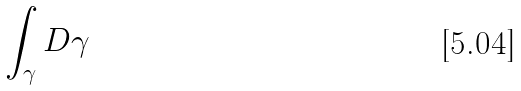Convert formula to latex. <formula><loc_0><loc_0><loc_500><loc_500>\int _ { \gamma } D \gamma</formula> 